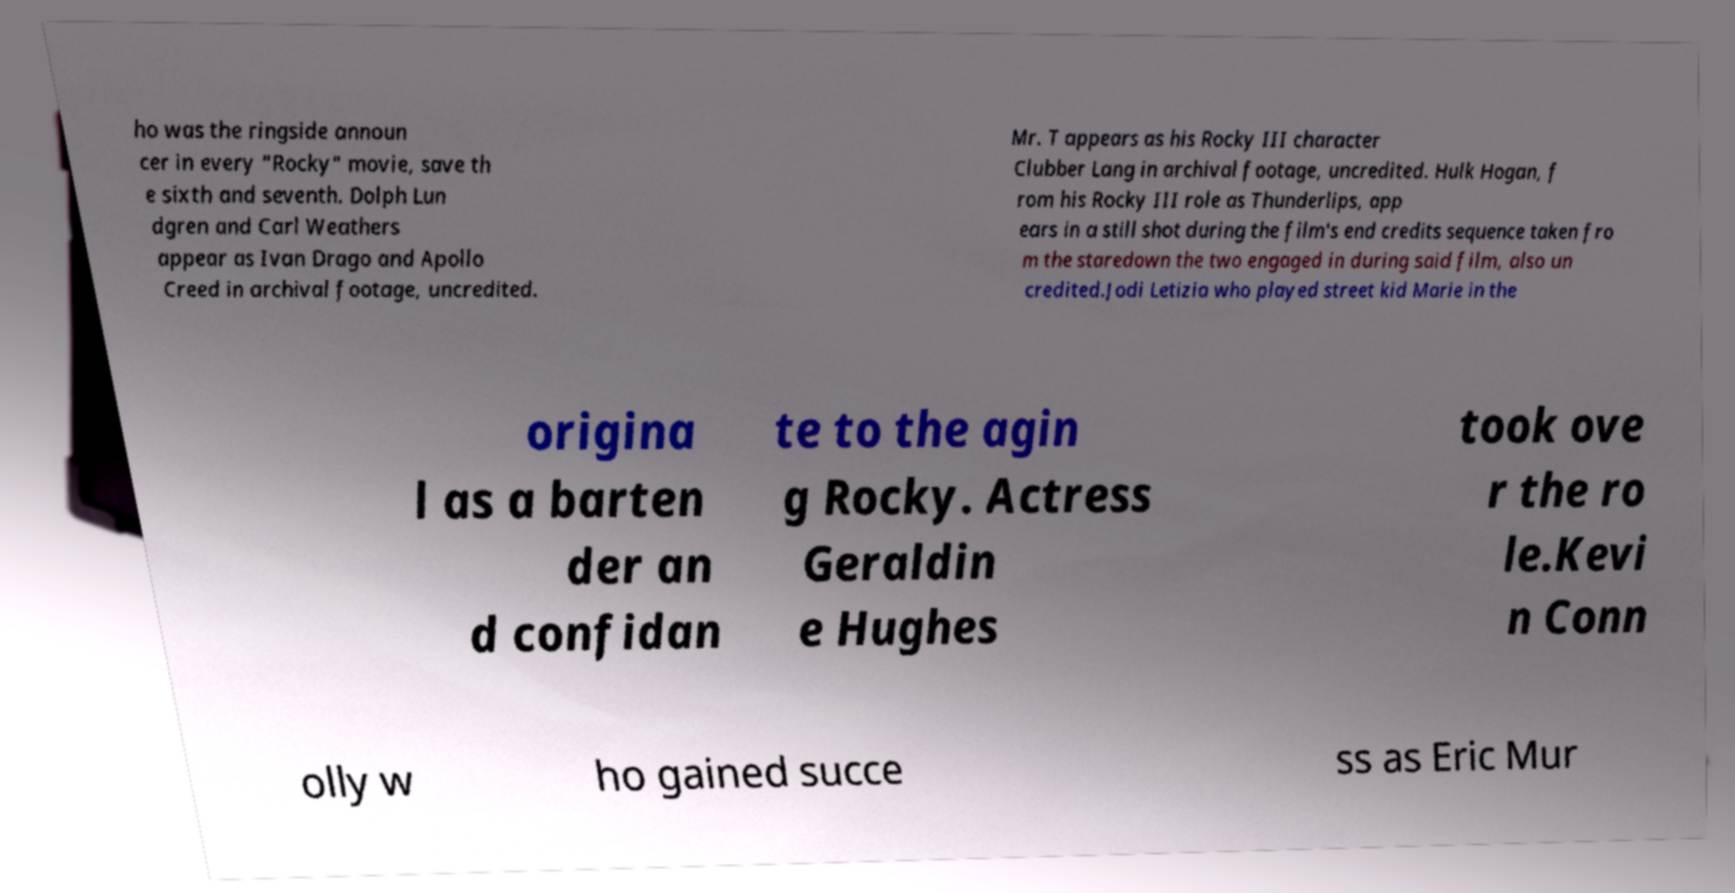What messages or text are displayed in this image? I need them in a readable, typed format. ho was the ringside announ cer in every "Rocky" movie, save th e sixth and seventh. Dolph Lun dgren and Carl Weathers appear as Ivan Drago and Apollo Creed in archival footage, uncredited. Mr. T appears as his Rocky III character Clubber Lang in archival footage, uncredited. Hulk Hogan, f rom his Rocky III role as Thunderlips, app ears in a still shot during the film's end credits sequence taken fro m the staredown the two engaged in during said film, also un credited.Jodi Letizia who played street kid Marie in the origina l as a barten der an d confidan te to the agin g Rocky. Actress Geraldin e Hughes took ove r the ro le.Kevi n Conn olly w ho gained succe ss as Eric Mur 